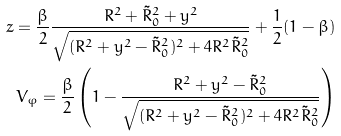Convert formula to latex. <formula><loc_0><loc_0><loc_500><loc_500>z = \frac { \beta } { 2 } \frac { R ^ { 2 } + \tilde { R } _ { 0 } ^ { 2 } + y ^ { 2 } } { \sqrt { ( R ^ { 2 } + y ^ { 2 } - \tilde { R } _ { 0 } ^ { 2 } ) ^ { 2 } + 4 R ^ { 2 } \tilde { R } _ { 0 } ^ { 2 } } } + \frac { 1 } { 2 } ( 1 - \beta ) \\ V _ { \varphi } = \frac { \beta } { 2 } \left ( 1 - \frac { R ^ { 2 } + y ^ { 2 } - \tilde { R } _ { 0 } ^ { 2 } } { \sqrt { ( R ^ { 2 } + y ^ { 2 } - \tilde { R } _ { 0 } ^ { 2 } ) ^ { 2 } + 4 R ^ { 2 } \tilde { R } _ { 0 } ^ { 2 } } } \right )</formula> 